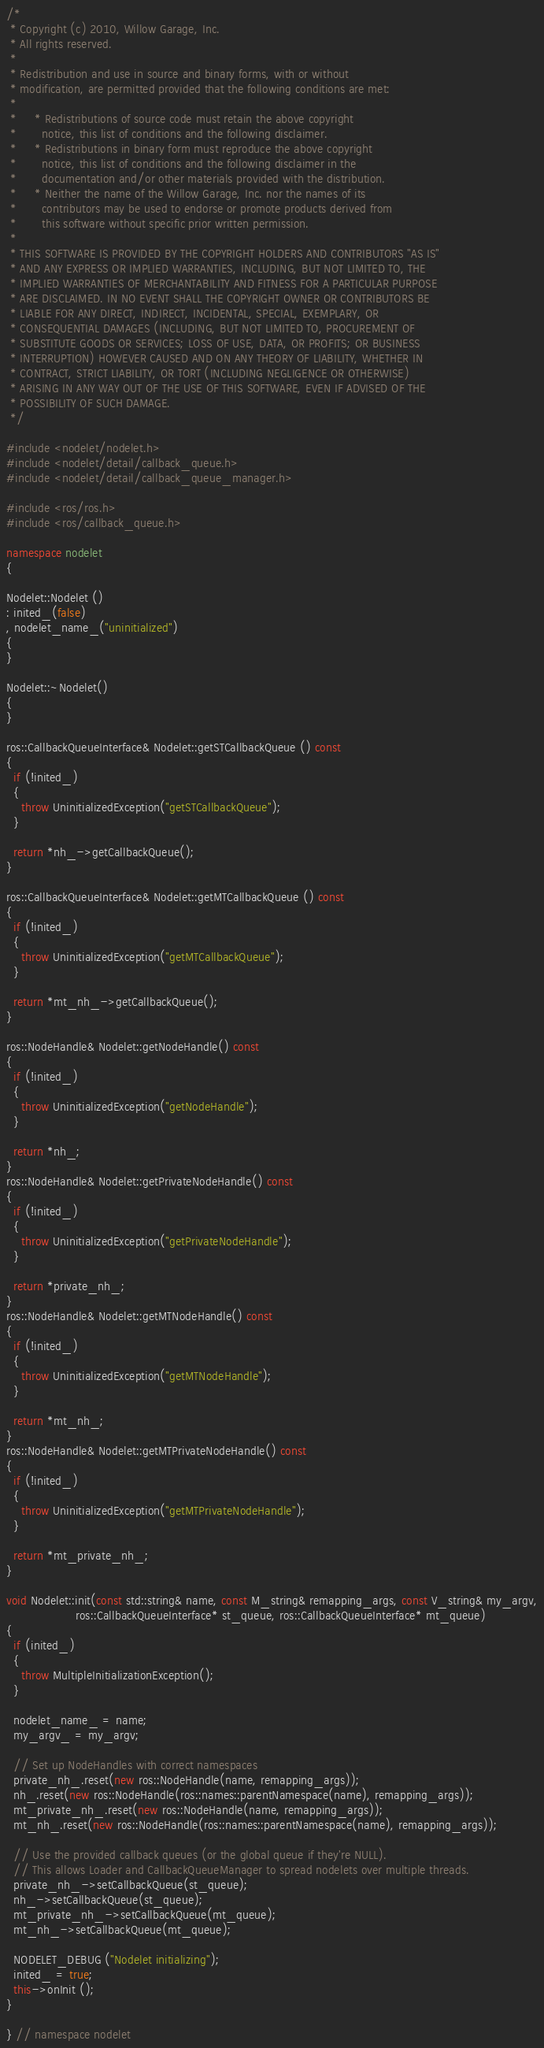Convert code to text. <code><loc_0><loc_0><loc_500><loc_500><_C++_>/*
 * Copyright (c) 2010, Willow Garage, Inc.
 * All rights reserved.
 *
 * Redistribution and use in source and binary forms, with or without
 * modification, are permitted provided that the following conditions are met:
 *
 *     * Redistributions of source code must retain the above copyright
 *       notice, this list of conditions and the following disclaimer.
 *     * Redistributions in binary form must reproduce the above copyright
 *       notice, this list of conditions and the following disclaimer in the
 *       documentation and/or other materials provided with the distribution.
 *     * Neither the name of the Willow Garage, Inc. nor the names of its
 *       contributors may be used to endorse or promote products derived from
 *       this software without specific prior written permission.
 *
 * THIS SOFTWARE IS PROVIDED BY THE COPYRIGHT HOLDERS AND CONTRIBUTORS "AS IS"
 * AND ANY EXPRESS OR IMPLIED WARRANTIES, INCLUDING, BUT NOT LIMITED TO, THE
 * IMPLIED WARRANTIES OF MERCHANTABILITY AND FITNESS FOR A PARTICULAR PURPOSE
 * ARE DISCLAIMED. IN NO EVENT SHALL THE COPYRIGHT OWNER OR CONTRIBUTORS BE
 * LIABLE FOR ANY DIRECT, INDIRECT, INCIDENTAL, SPECIAL, EXEMPLARY, OR
 * CONSEQUENTIAL DAMAGES (INCLUDING, BUT NOT LIMITED TO, PROCUREMENT OF
 * SUBSTITUTE GOODS OR SERVICES; LOSS OF USE, DATA, OR PROFITS; OR BUSINESS
 * INTERRUPTION) HOWEVER CAUSED AND ON ANY THEORY OF LIABILITY, WHETHER IN
 * CONTRACT, STRICT LIABILITY, OR TORT (INCLUDING NEGLIGENCE OR OTHERWISE)
 * ARISING IN ANY WAY OUT OF THE USE OF THIS SOFTWARE, EVEN IF ADVISED OF THE
 * POSSIBILITY OF SUCH DAMAGE.
 */

#include <nodelet/nodelet.h>
#include <nodelet/detail/callback_queue.h>
#include <nodelet/detail/callback_queue_manager.h>

#include <ros/ros.h>
#include <ros/callback_queue.h>

namespace nodelet
{

Nodelet::Nodelet ()
: inited_(false)
, nodelet_name_("uninitialized")
{
}

Nodelet::~Nodelet()
{
}

ros::CallbackQueueInterface& Nodelet::getSTCallbackQueue () const
{
  if (!inited_)
  {
    throw UninitializedException("getSTCallbackQueue");
  }

  return *nh_->getCallbackQueue();
}

ros::CallbackQueueInterface& Nodelet::getMTCallbackQueue () const
{
  if (!inited_)
  {
    throw UninitializedException("getMTCallbackQueue");
  }

  return *mt_nh_->getCallbackQueue();
}

ros::NodeHandle& Nodelet::getNodeHandle() const
{
  if (!inited_)
  {
    throw UninitializedException("getNodeHandle");
  }

  return *nh_;
}
ros::NodeHandle& Nodelet::getPrivateNodeHandle() const
{
  if (!inited_)
  {
    throw UninitializedException("getPrivateNodeHandle");
  }

  return *private_nh_;
}
ros::NodeHandle& Nodelet::getMTNodeHandle() const
{
  if (!inited_)
  {
    throw UninitializedException("getMTNodeHandle");
  }

  return *mt_nh_;
}
ros::NodeHandle& Nodelet::getMTPrivateNodeHandle() const
{
  if (!inited_)
  {
    throw UninitializedException("getMTPrivateNodeHandle");
  }

  return *mt_private_nh_;
}

void Nodelet::init(const std::string& name, const M_string& remapping_args, const V_string& my_argv,
                   ros::CallbackQueueInterface* st_queue, ros::CallbackQueueInterface* mt_queue)
{
  if (inited_)
  {
    throw MultipleInitializationException();
  }

  nodelet_name_ = name;
  my_argv_ = my_argv;

  // Set up NodeHandles with correct namespaces
  private_nh_.reset(new ros::NodeHandle(name, remapping_args));
  nh_.reset(new ros::NodeHandle(ros::names::parentNamespace(name), remapping_args));
  mt_private_nh_.reset(new ros::NodeHandle(name, remapping_args));
  mt_nh_.reset(new ros::NodeHandle(ros::names::parentNamespace(name), remapping_args));

  // Use the provided callback queues (or the global queue if they're NULL).
  // This allows Loader and CallbackQueueManager to spread nodelets over multiple threads.
  private_nh_->setCallbackQueue(st_queue);
  nh_->setCallbackQueue(st_queue);
  mt_private_nh_->setCallbackQueue(mt_queue);
  mt_nh_->setCallbackQueue(mt_queue);
  
  NODELET_DEBUG ("Nodelet initializing");
  inited_ = true;
  this->onInit ();
}

} // namespace nodelet
</code> 